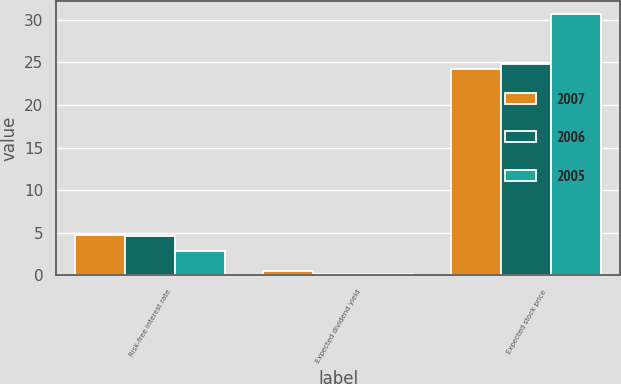<chart> <loc_0><loc_0><loc_500><loc_500><stacked_bar_chart><ecel><fcel>Risk-free interest rate<fcel>Expected dividend yield<fcel>Expected stock price<nl><fcel>2007<fcel>4.8<fcel>0.5<fcel>24.2<nl><fcel>2006<fcel>4.6<fcel>0.2<fcel>24.8<nl><fcel>2005<fcel>2.9<fcel>0.2<fcel>30.7<nl></chart> 